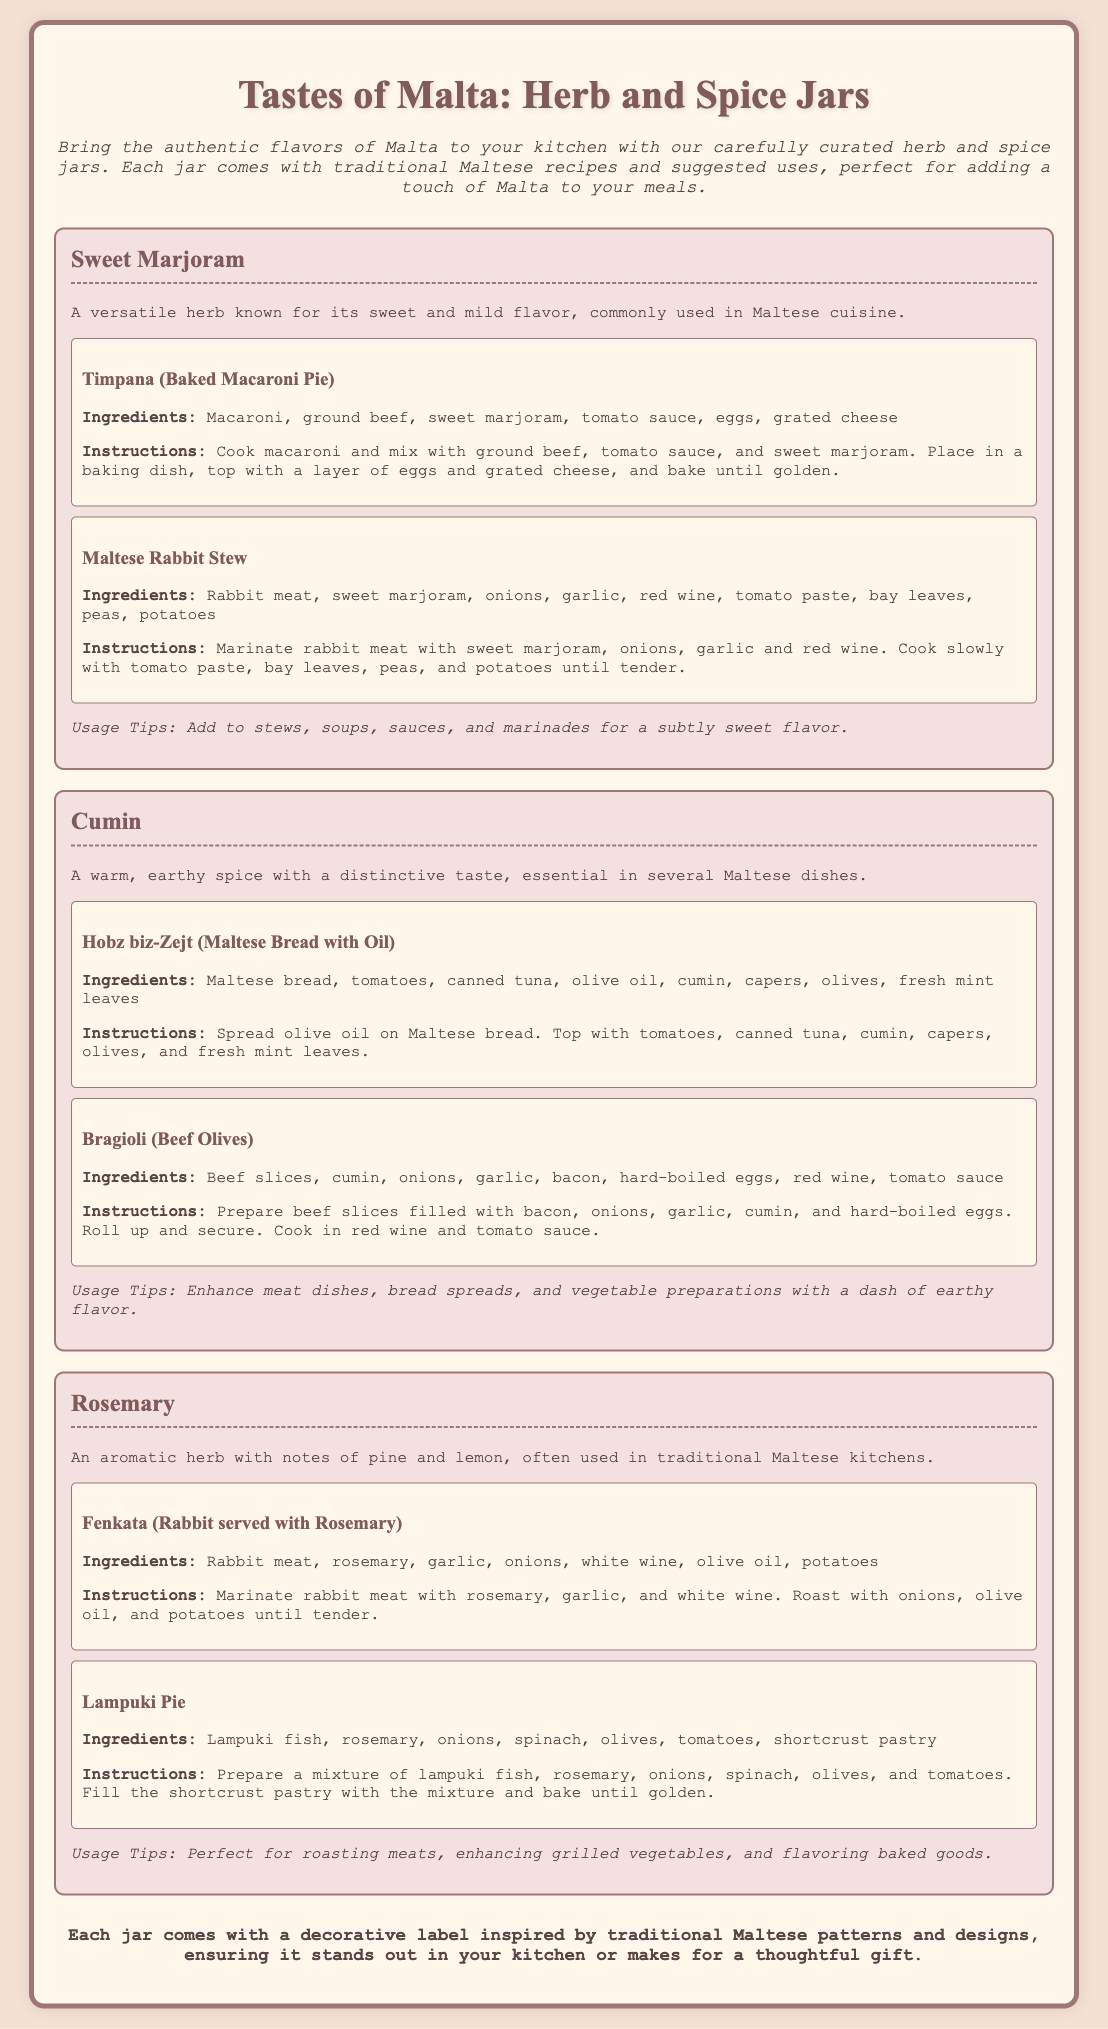What are the main ingredients in Timpana? The ingredients for Timpana include macaroni, ground beef, sweet marjoram, tomato sauce, eggs, and grated cheese.
Answer: macaroni, ground beef, sweet marjoram, tomato sauce, eggs, grated cheese What herb is included in Maltese Rabbit Stew? The herb used in Maltese Rabbit Stew is sweet marjoram, as mentioned in the recipe.
Answer: sweet marjoram What is the usage tip for Cumin? The usage tip for Cumin suggests enhancing meat dishes, bread spreads, and vegetable preparations with a dash of earthy flavor.
Answer: Enhance meat dishes, bread spreads, and vegetable preparations How many jars of herbs and spices are listed? There are three jars listed in the document, each representing a different herb or spice.
Answer: three What is the cooking method for the Fenkata dish? The cooking method for Fenkata involves marinating and roasting rabbit meat with rosemary and other ingredients.
Answer: marinating and roasting Which spice is referred to as a warm, earthy spice? The spice described as warm and earthy is Cumin, according to its description.
Answer: Cumin What is the decorative feature of each jar? Each jar comes with a decorative label inspired by traditional Maltese patterns and designs.
Answer: decorative label What is the traditional dish made with Rosemary? The traditional dish made with Rosemary is Fenkata, which is rabbit served with Rosemary.
Answer: Fenkata 